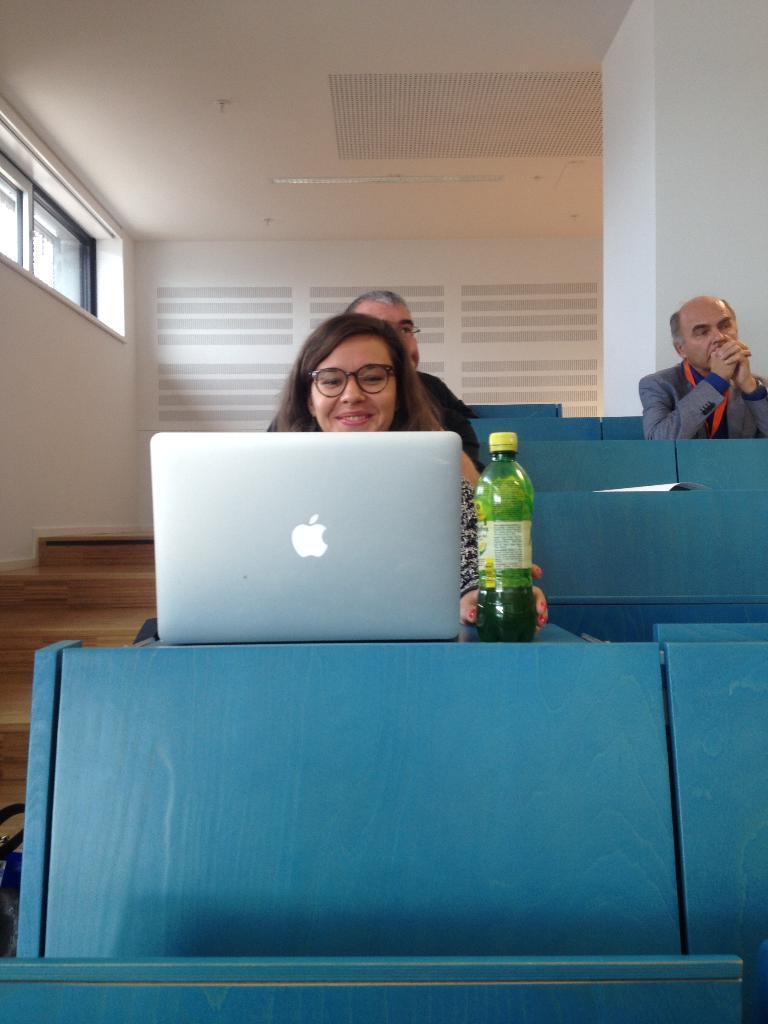Could you give a brief overview of what you see in this image? 3 people are seated on the blue chairs. on the table there is a laptop and a green bottle. at the right there are stairs. behind them there is a white wall. the person at the front is wearing spectacles and smiling. 